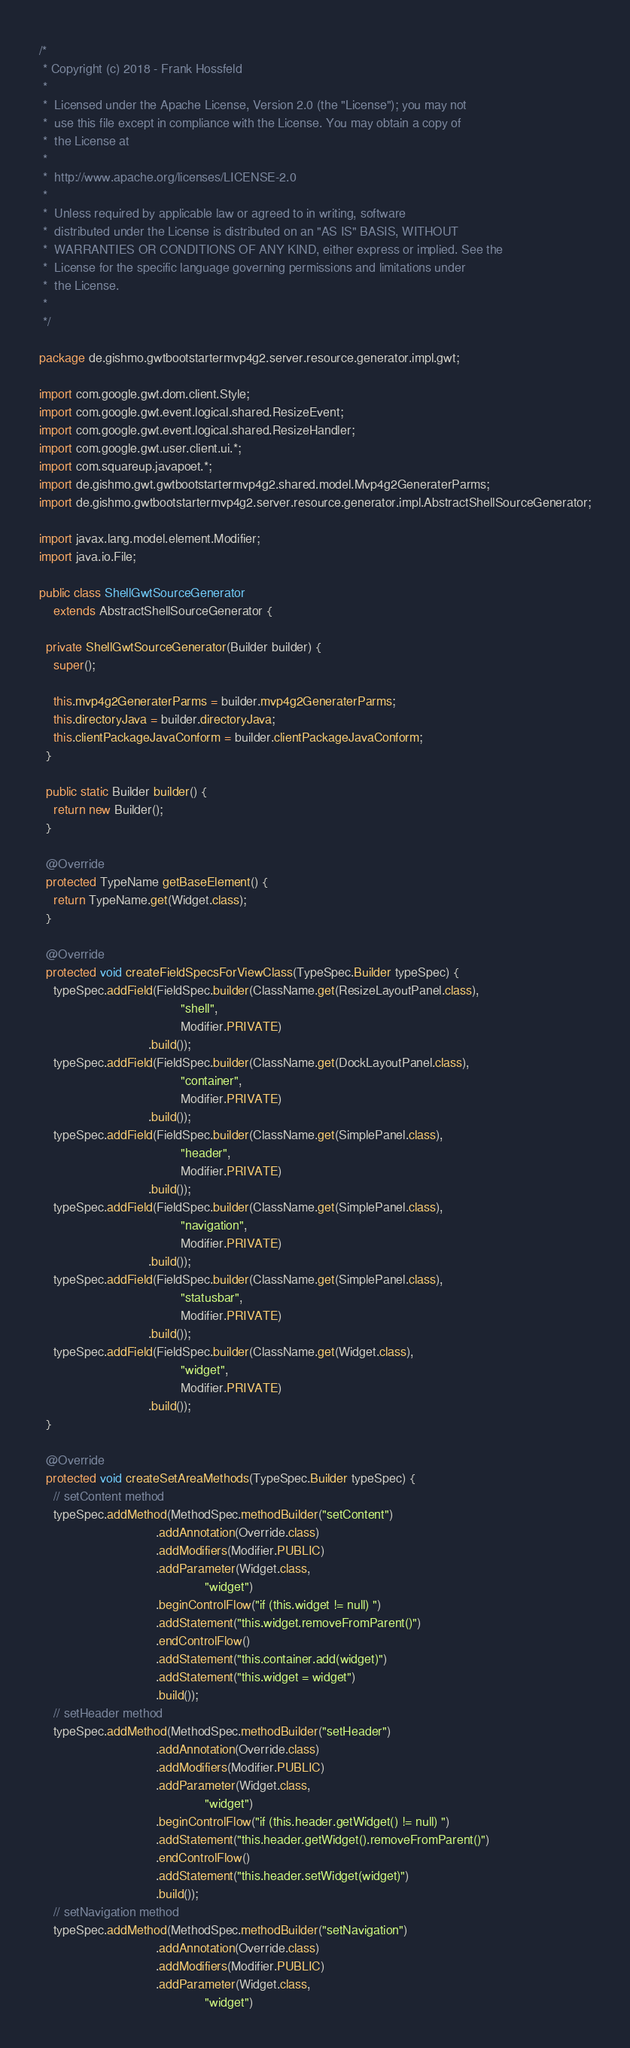Convert code to text. <code><loc_0><loc_0><loc_500><loc_500><_Java_>/*
 * Copyright (c) 2018 - Frank Hossfeld
 *
 *  Licensed under the Apache License, Version 2.0 (the "License"); you may not
 *  use this file except in compliance with the License. You may obtain a copy of
 *  the License at
 *
 *  http://www.apache.org/licenses/LICENSE-2.0
 *
 *  Unless required by applicable law or agreed to in writing, software
 *  distributed under the License is distributed on an "AS IS" BASIS, WITHOUT
 *  WARRANTIES OR CONDITIONS OF ANY KIND, either express or implied. See the
 *  License for the specific language governing permissions and limitations under
 *  the License.
 *
 */

package de.gishmo.gwtbootstartermvp4g2.server.resource.generator.impl.gwt;

import com.google.gwt.dom.client.Style;
import com.google.gwt.event.logical.shared.ResizeEvent;
import com.google.gwt.event.logical.shared.ResizeHandler;
import com.google.gwt.user.client.ui.*;
import com.squareup.javapoet.*;
import de.gishmo.gwt.gwtbootstartermvp4g2.shared.model.Mvp4g2GeneraterParms;
import de.gishmo.gwtbootstartermvp4g2.server.resource.generator.impl.AbstractShellSourceGenerator;

import javax.lang.model.element.Modifier;
import java.io.File;

public class ShellGwtSourceGenerator
    extends AbstractShellSourceGenerator {

  private ShellGwtSourceGenerator(Builder builder) {
    super();

    this.mvp4g2GeneraterParms = builder.mvp4g2GeneraterParms;
    this.directoryJava = builder.directoryJava;
    this.clientPackageJavaConform = builder.clientPackageJavaConform;
  }

  public static Builder builder() {
    return new Builder();
  }

  @Override
  protected TypeName getBaseElement() {
    return TypeName.get(Widget.class);
  }

  @Override
  protected void createFieldSpecsForViewClass(TypeSpec.Builder typeSpec) {
    typeSpec.addField(FieldSpec.builder(ClassName.get(ResizeLayoutPanel.class),
                                        "shell",
                                        Modifier.PRIVATE)
                               .build());
    typeSpec.addField(FieldSpec.builder(ClassName.get(DockLayoutPanel.class),
                                        "container",
                                        Modifier.PRIVATE)
                               .build());
    typeSpec.addField(FieldSpec.builder(ClassName.get(SimplePanel.class),
                                        "header",
                                        Modifier.PRIVATE)
                               .build());
    typeSpec.addField(FieldSpec.builder(ClassName.get(SimplePanel.class),
                                        "navigation",
                                        Modifier.PRIVATE)
                               .build());
    typeSpec.addField(FieldSpec.builder(ClassName.get(SimplePanel.class),
                                        "statusbar",
                                        Modifier.PRIVATE)
                               .build());
    typeSpec.addField(FieldSpec.builder(ClassName.get(Widget.class),
                                        "widget",
                                        Modifier.PRIVATE)
                               .build());
  }

  @Override
  protected void createSetAreaMethods(TypeSpec.Builder typeSpec) {
    // setContent method
    typeSpec.addMethod(MethodSpec.methodBuilder("setContent")
                                 .addAnnotation(Override.class)
                                 .addModifiers(Modifier.PUBLIC)
                                 .addParameter(Widget.class,
                                               "widget")
                                 .beginControlFlow("if (this.widget != null) ")
                                 .addStatement("this.widget.removeFromParent()")
                                 .endControlFlow()
                                 .addStatement("this.container.add(widget)")
                                 .addStatement("this.widget = widget")
                                 .build());
    // setHeader method
    typeSpec.addMethod(MethodSpec.methodBuilder("setHeader")
                                 .addAnnotation(Override.class)
                                 .addModifiers(Modifier.PUBLIC)
                                 .addParameter(Widget.class,
                                               "widget")
                                 .beginControlFlow("if (this.header.getWidget() != null) ")
                                 .addStatement("this.header.getWidget().removeFromParent()")
                                 .endControlFlow()
                                 .addStatement("this.header.setWidget(widget)")
                                 .build());
    // setNavigation method
    typeSpec.addMethod(MethodSpec.methodBuilder("setNavigation")
                                 .addAnnotation(Override.class)
                                 .addModifiers(Modifier.PUBLIC)
                                 .addParameter(Widget.class,
                                               "widget")</code> 